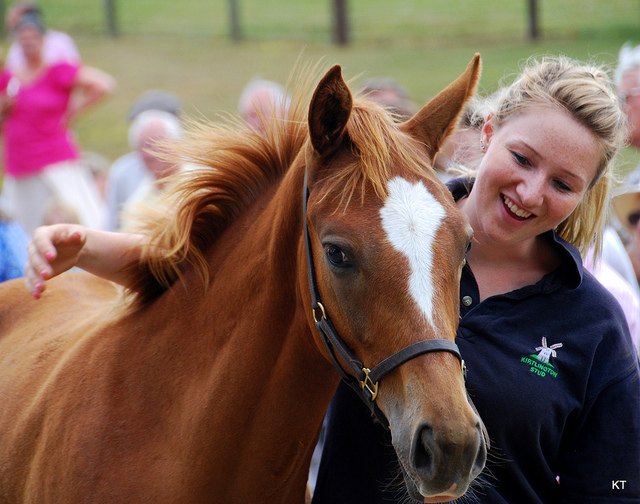Identify the text contained in this image. KT 